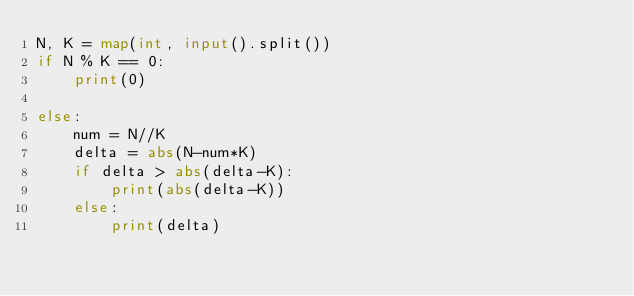Convert code to text. <code><loc_0><loc_0><loc_500><loc_500><_Python_>N, K = map(int, input().split())
if N % K == 0:
    print(0)

else:
    num = N//K
    delta = abs(N-num*K)
    if delta > abs(delta-K):
        print(abs(delta-K))
    else:
        print(delta)



</code> 